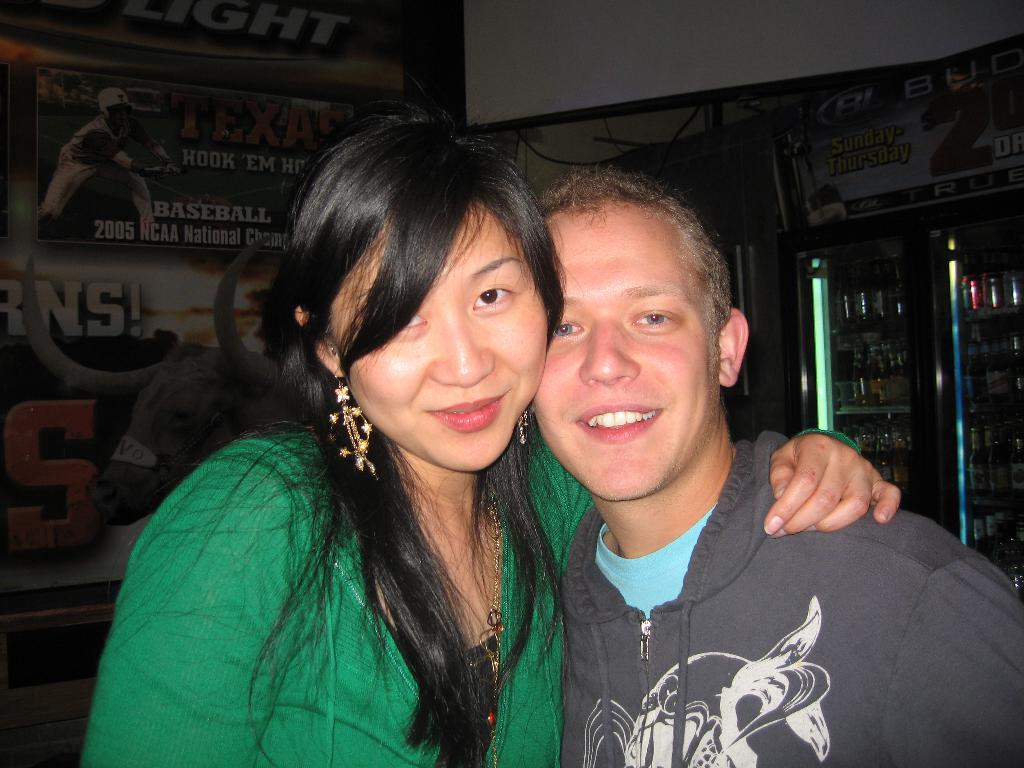How many people are in the image? There are two people in the image. What colors are the dresses worn by the people in the image? One person is wearing a green dress, and the other person is wearing a grey dress. Is there a third person in the image? No, there are only two people in the image. What can be seen in the background of the image? There is a banner in the background of the image. What is inside the refrigerator in the image? There are items inside a refrigerator in the image. How does the person in the blue dress support the washing machine in the image? There is no washing machine present in the image, so the person in the blue dress cannot support one. 